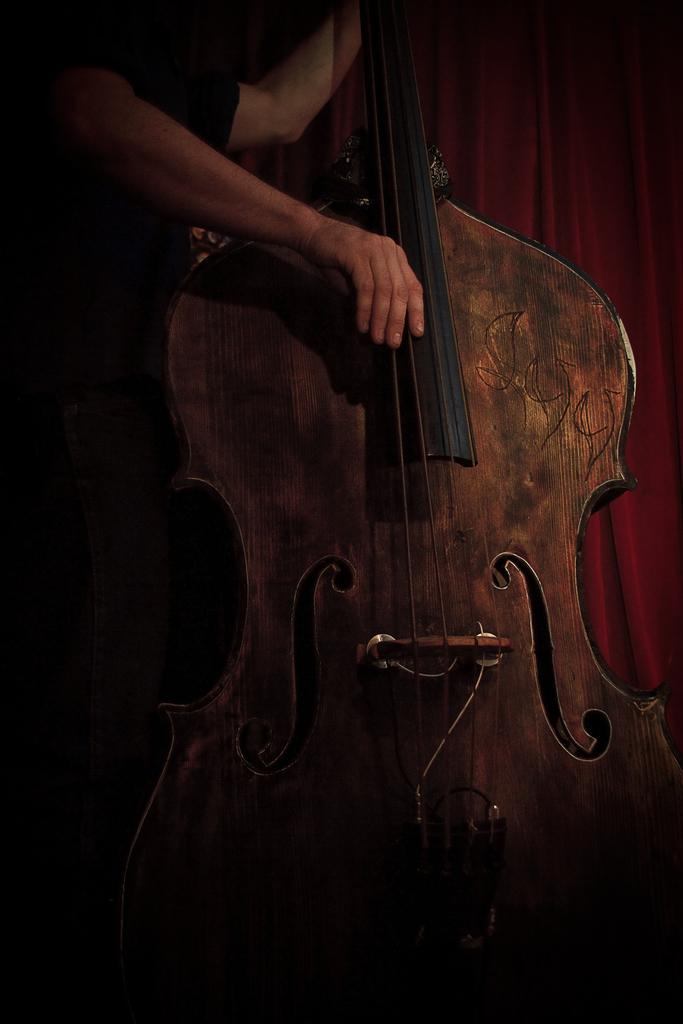What is the main subject of the image? There is a person in the image. What is the person holding in the image? The person is holding a guitar. What can be seen in the background of the image? There is a curtain in the background of the image. What type of friction can be observed between the person and the guitar in the image? There is no indication of friction between the person and the guitar in the image. What taste does the guitar have in the image? Guitars do not have a taste, as they are not edible. 